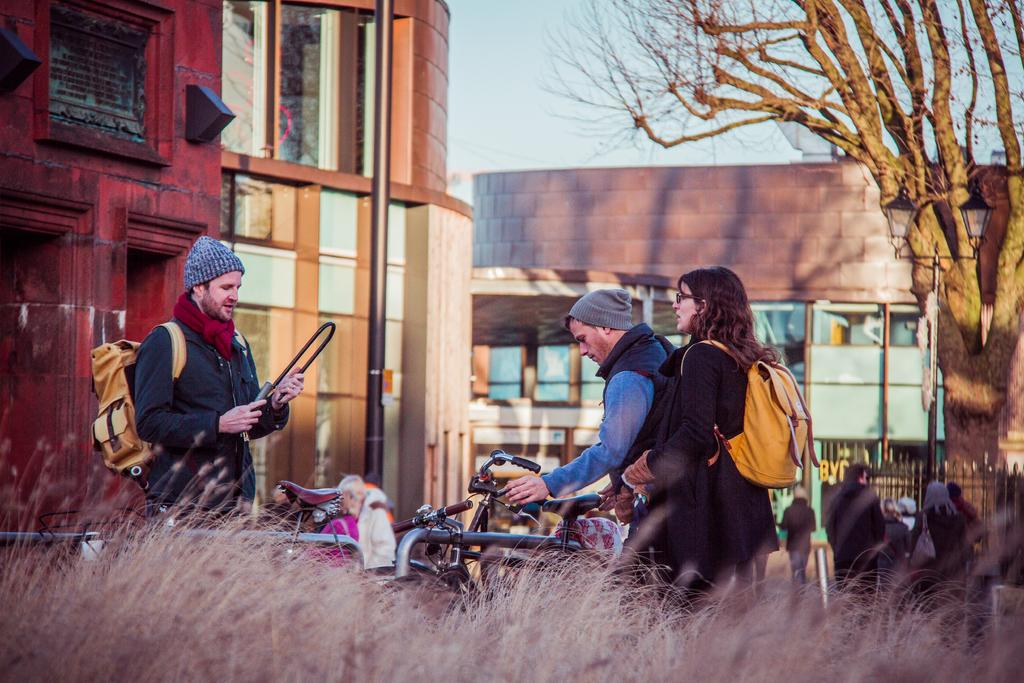What type of structure is present in the image? There is a building in the image. What natural element can be seen in the image? There is a tree in the image. Are there any individuals visible in the image? Yes, there are people standing in the image. What is the man holding in the image? The man is holding a bicycle in the image. What type of ground surface is visible in the image? There is grass visible in the image. Can you see a bottle in the hand of the person standing next to the tree? There is no bottle or person standing next to the tree in the image. Is there a rabbit hopping through the grass in the image? There is no rabbit present in the image. 